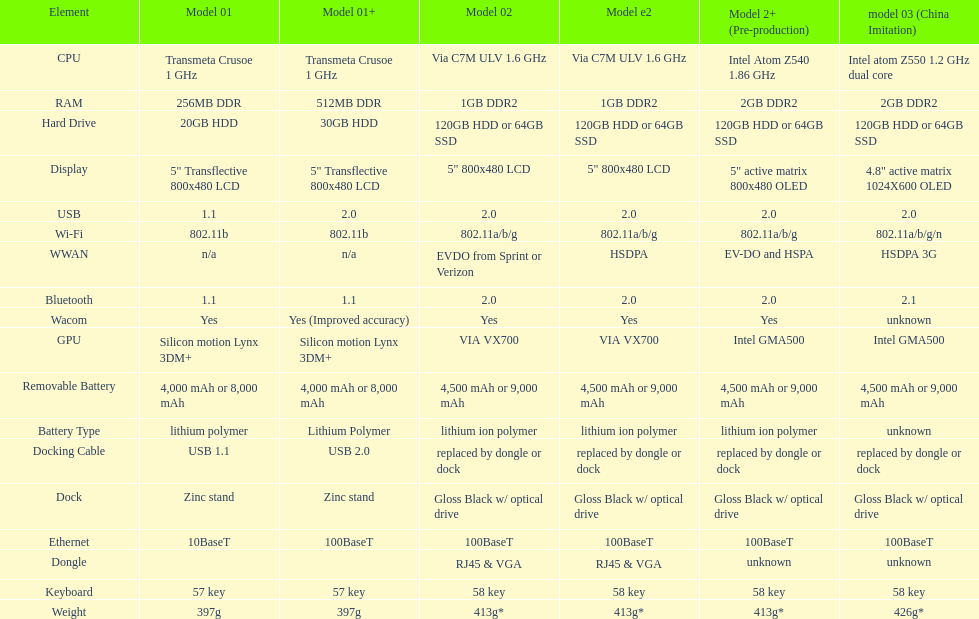The model 2 and the model 2e have what type of cpu? Via C7M ULV 1.6 GHz. 